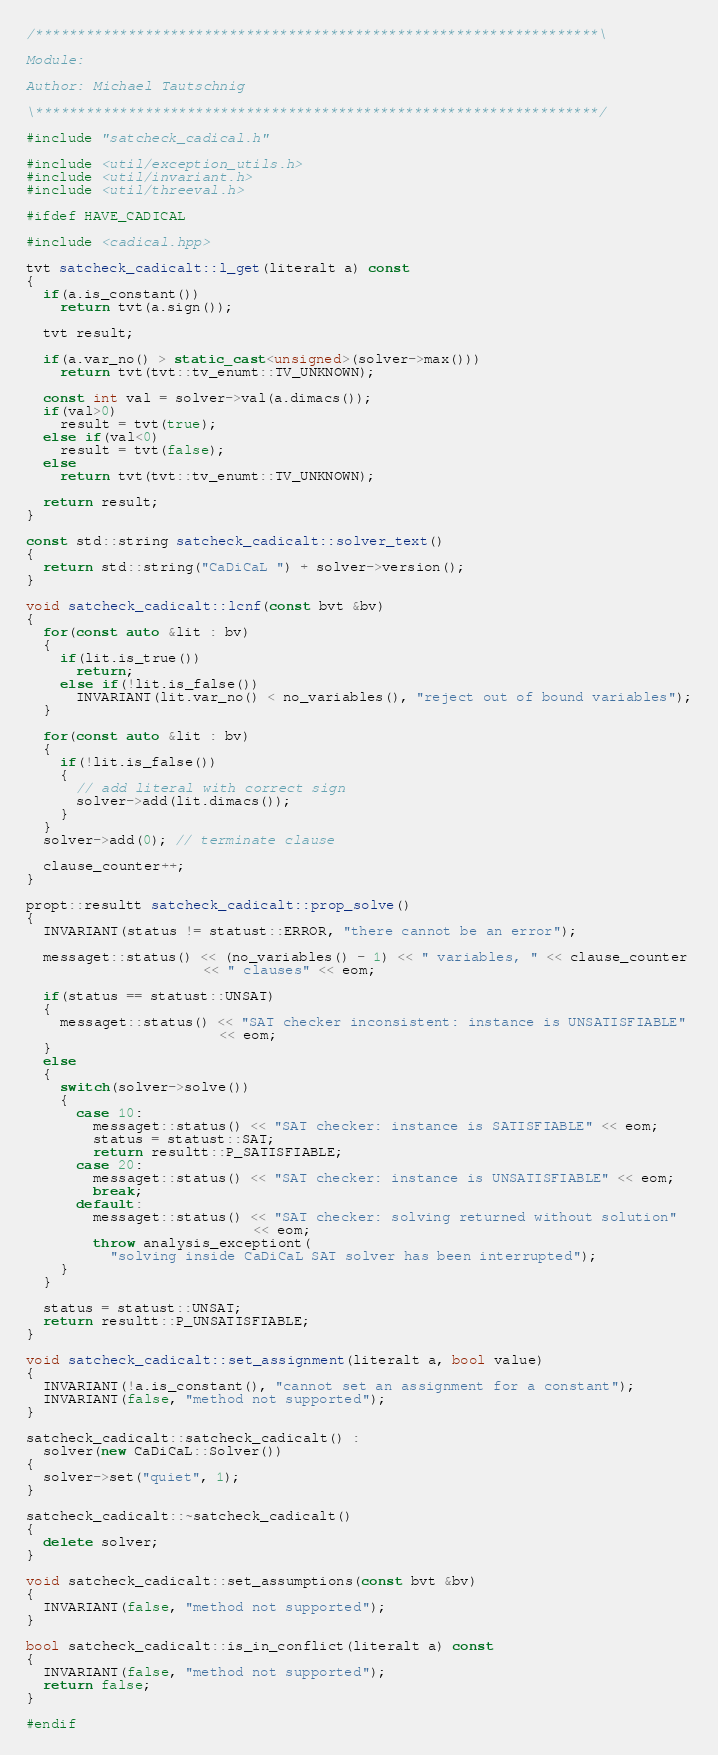Convert code to text. <code><loc_0><loc_0><loc_500><loc_500><_C++_>/*******************************************************************\

Module:

Author: Michael Tautschnig

\*******************************************************************/

#include "satcheck_cadical.h"

#include <util/exception_utils.h>
#include <util/invariant.h>
#include <util/threeval.h>

#ifdef HAVE_CADICAL

#include <cadical.hpp>

tvt satcheck_cadicalt::l_get(literalt a) const
{
  if(a.is_constant())
    return tvt(a.sign());

  tvt result;

  if(a.var_no() > static_cast<unsigned>(solver->max()))
    return tvt(tvt::tv_enumt::TV_UNKNOWN);

  const int val = solver->val(a.dimacs());
  if(val>0)
    result = tvt(true);
  else if(val<0)
    result = tvt(false);
  else
    return tvt(tvt::tv_enumt::TV_UNKNOWN);

  return result;
}

const std::string satcheck_cadicalt::solver_text()
{
  return std::string("CaDiCaL ") + solver->version();
}

void satcheck_cadicalt::lcnf(const bvt &bv)
{
  for(const auto &lit : bv)
  {
    if(lit.is_true())
      return;
    else if(!lit.is_false())
      INVARIANT(lit.var_no() < no_variables(), "reject out of bound variables");
  }

  for(const auto &lit : bv)
  {
    if(!lit.is_false())
    {
      // add literal with correct sign
      solver->add(lit.dimacs());
    }
  }
  solver->add(0); // terminate clause

  clause_counter++;
}

propt::resultt satcheck_cadicalt::prop_solve()
{
  INVARIANT(status != statust::ERROR, "there cannot be an error");

  messaget::status() << (no_variables() - 1) << " variables, " << clause_counter
                     << " clauses" << eom;

  if(status == statust::UNSAT)
  {
    messaget::status() << "SAT checker inconsistent: instance is UNSATISFIABLE"
                       << eom;
  }
  else
  {
    switch(solver->solve())
    {
      case 10:
        messaget::status() << "SAT checker: instance is SATISFIABLE" << eom;
        status = statust::SAT;
        return resultt::P_SATISFIABLE;
      case 20:
        messaget::status() << "SAT checker: instance is UNSATISFIABLE" << eom;
        break;
      default:
        messaget::status() << "SAT checker: solving returned without solution"
                           << eom;
        throw analysis_exceptiont(
          "solving inside CaDiCaL SAT solver has been interrupted");
    }
  }

  status = statust::UNSAT;
  return resultt::P_UNSATISFIABLE;
}

void satcheck_cadicalt::set_assignment(literalt a, bool value)
{
  INVARIANT(!a.is_constant(), "cannot set an assignment for a constant");
  INVARIANT(false, "method not supported");
}

satcheck_cadicalt::satcheck_cadicalt() :
  solver(new CaDiCaL::Solver())
{
  solver->set("quiet", 1);
}

satcheck_cadicalt::~satcheck_cadicalt()
{
  delete solver;
}

void satcheck_cadicalt::set_assumptions(const bvt &bv)
{
  INVARIANT(false, "method not supported");
}

bool satcheck_cadicalt::is_in_conflict(literalt a) const
{
  INVARIANT(false, "method not supported");
  return false;
}

#endif
</code> 